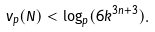Convert formula to latex. <formula><loc_0><loc_0><loc_500><loc_500>v _ { p } ( N ) < \log _ { p } ( 6 k ^ { 3 n + 3 } ) .</formula> 